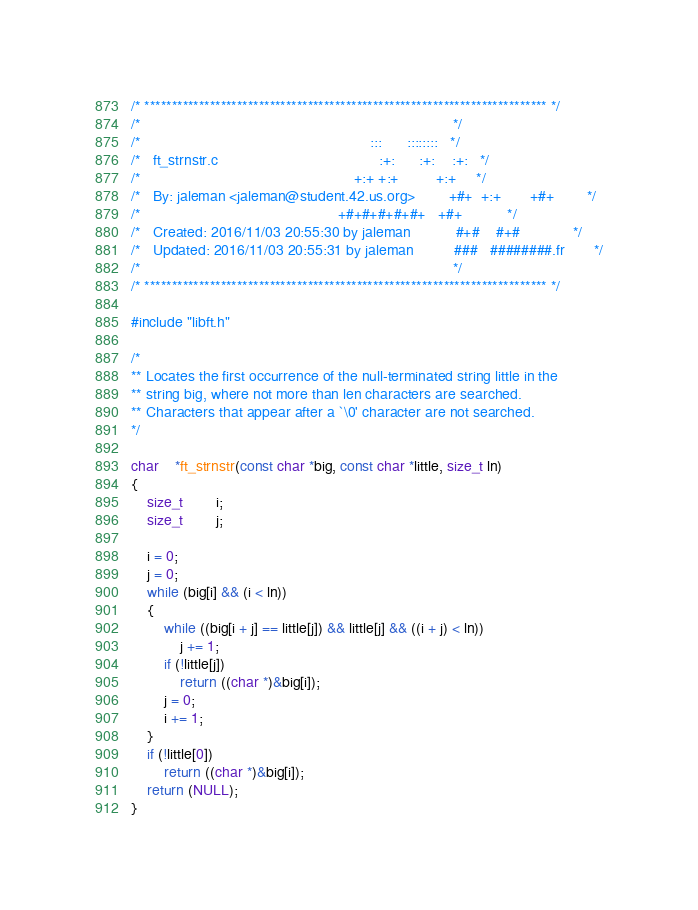Convert code to text. <code><loc_0><loc_0><loc_500><loc_500><_C_>/* ************************************************************************** */
/*                                                                            */
/*                                                        :::      ::::::::   */
/*   ft_strnstr.c                                       :+:      :+:    :+:   */
/*                                                    +:+ +:+         +:+     */
/*   By: jaleman <jaleman@student.42.us.org>        +#+  +:+       +#+        */
/*                                                +#+#+#+#+#+   +#+           */
/*   Created: 2016/11/03 20:55:30 by jaleman           #+#    #+#             */
/*   Updated: 2016/11/03 20:55:31 by jaleman          ###   ########.fr       */
/*                                                                            */
/* ************************************************************************** */

#include "libft.h"

/*
** Locates the first occurrence of the null-terminated string little in the
** string big, where not more than len characters are searched.
** Characters that appear after a `\0' character are not searched.
*/

char	*ft_strnstr(const char *big, const char *little, size_t ln)
{
	size_t		i;
	size_t		j;

	i = 0;
	j = 0;
	while (big[i] && (i < ln))
	{
		while ((big[i + j] == little[j]) && little[j] && ((i + j) < ln))
			j += 1;
		if (!little[j])
			return ((char *)&big[i]);
		j = 0;
		i += 1;
	}
	if (!little[0])
		return ((char *)&big[i]);
	return (NULL);
}
</code> 